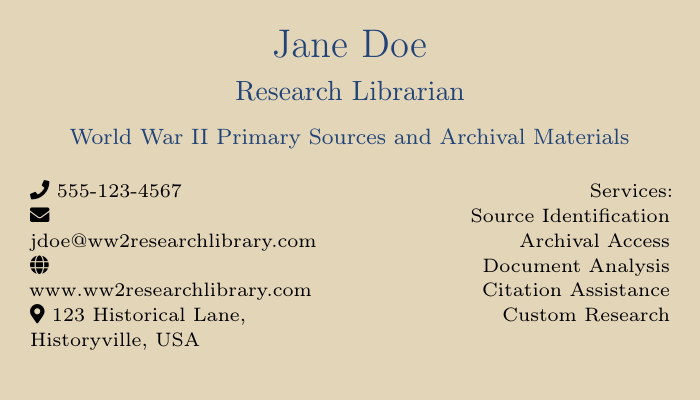What is the name of the research librarian? The name is prominently displayed at the top of the card.
Answer: Jane Doe What services are offered by the research librarian? The services section lists various types of assistance available.
Answer: Source Identification, Archival Access, Document Analysis, Citation Assistance, Custom Research What is the phone number provided? The phone number is indicated next to the phone icon.
Answer: 555-123-4567 What is the email address listed? The email address is next to the envelope icon on the card.
Answer: jdoe@ww2researchlibrary.com Where is the research librarian located? The address is shown near the map marker icon.
Answer: 123 Historical Lane, Historyville, USA What primary topic does this card focus on? The main topic is found in the subtitle under the librarian's title.
Answer: World War II Primary Sources and Archival Materials How many services are listed on the card? Counting the services in the designated area reveals the total.
Answer: Five What color is used as the background? The background color can be identified in the styling of the card.
Answer: Beige What website is provided on the card? The website is displayed near the globe icon.
Answer: www.ww2researchlibrary.com What font size is used for the librarian's title? The size is mentioned next to the title in the document format.
Answer: 10 